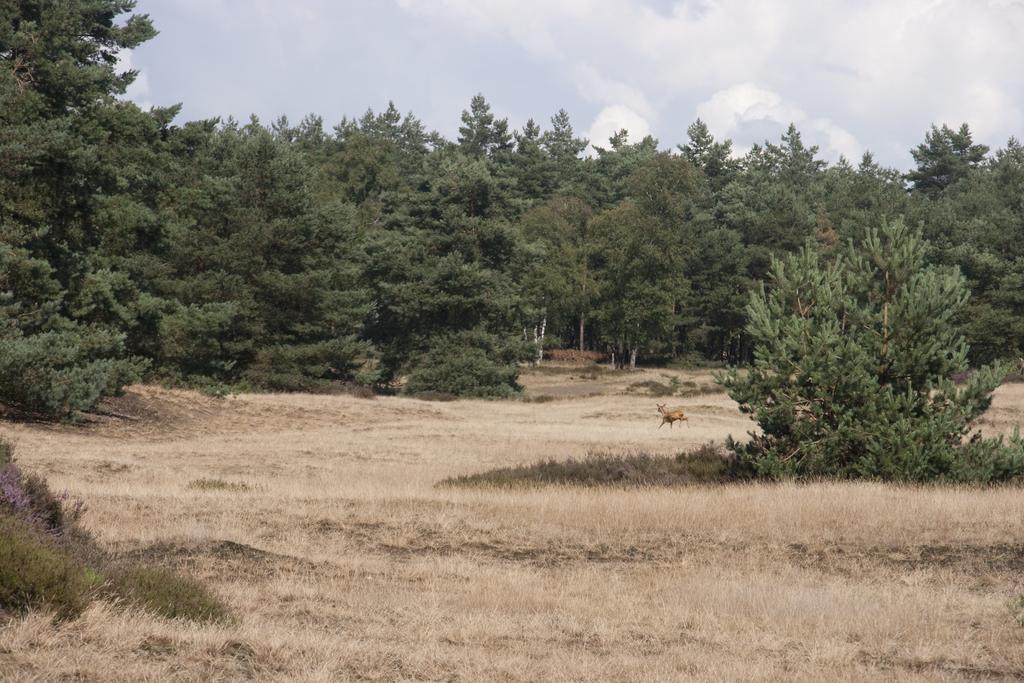Describe this image in one or two sentences. In this picture we can see an animal on the ground and in the background we can see trees, sky. 